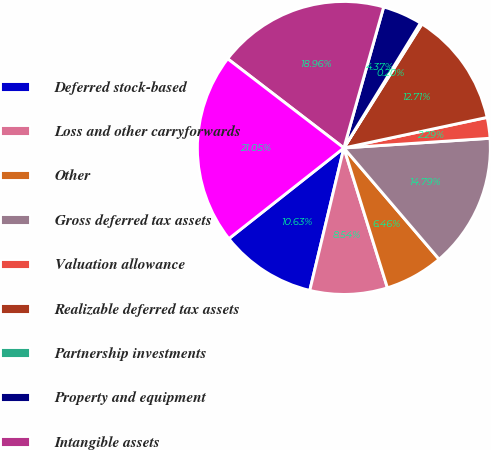<chart> <loc_0><loc_0><loc_500><loc_500><pie_chart><fcel>Deferred stock-based<fcel>Loss and other carryforwards<fcel>Other<fcel>Gross deferred tax assets<fcel>Valuation allowance<fcel>Realizable deferred tax assets<fcel>Partnership investments<fcel>Property and equipment<fcel>Intangible assets<fcel>Gross deferred tax liabilities<nl><fcel>10.63%<fcel>8.54%<fcel>6.46%<fcel>14.79%<fcel>2.29%<fcel>12.71%<fcel>0.2%<fcel>4.37%<fcel>18.96%<fcel>21.05%<nl></chart> 